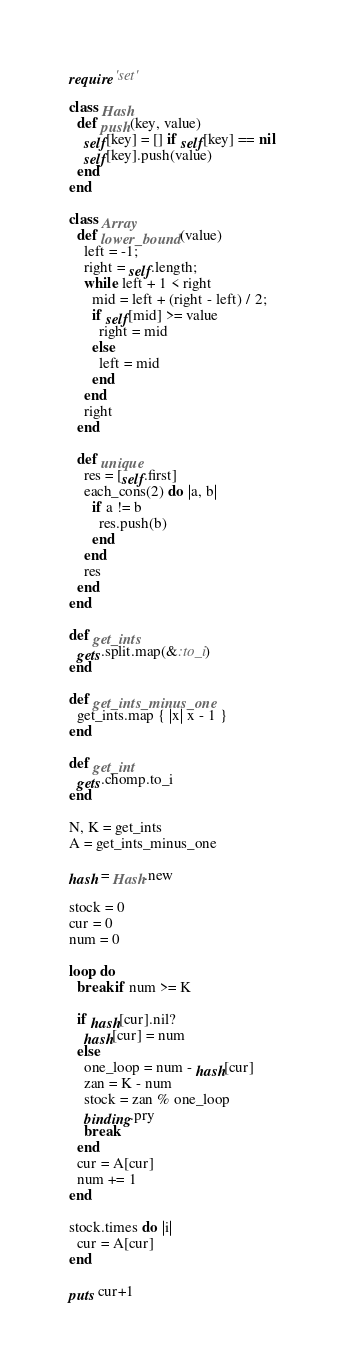Convert code to text. <code><loc_0><loc_0><loc_500><loc_500><_Ruby_>require 'set'

class Hash
  def push(key, value)
    self[key] = [] if self[key] == nil
    self[key].push(value)
  end
end

class Array
  def lower_bound(value)
    left = -1;
    right = self.length;
    while left + 1 < right
      mid = left + (right - left) / 2;
      if self[mid] >= value
        right = mid
      else
        left = mid
      end
    end
    right
  end

  def unique
    res = [self.first]
    each_cons(2) do |a, b|
      if a != b
        res.push(b)
      end
    end
    res
  end
end

def get_ints
  gets.split.map(&:to_i)
end

def get_ints_minus_one
  get_ints.map { |x| x - 1 }
end

def get_int
  gets.chomp.to_i
end

N, K = get_ints
A = get_ints_minus_one

hash = Hash.new

stock = 0
cur = 0
num = 0

loop do
  break if num >= K

  if hash[cur].nil?
    hash[cur] = num
  else
    one_loop = num - hash[cur]
    zan = K - num
    stock = zan % one_loop
    binding.pry
    break
  end
  cur = A[cur]
  num += 1
end

stock.times do |i|
  cur = A[cur]
end

puts cur+1
</code> 